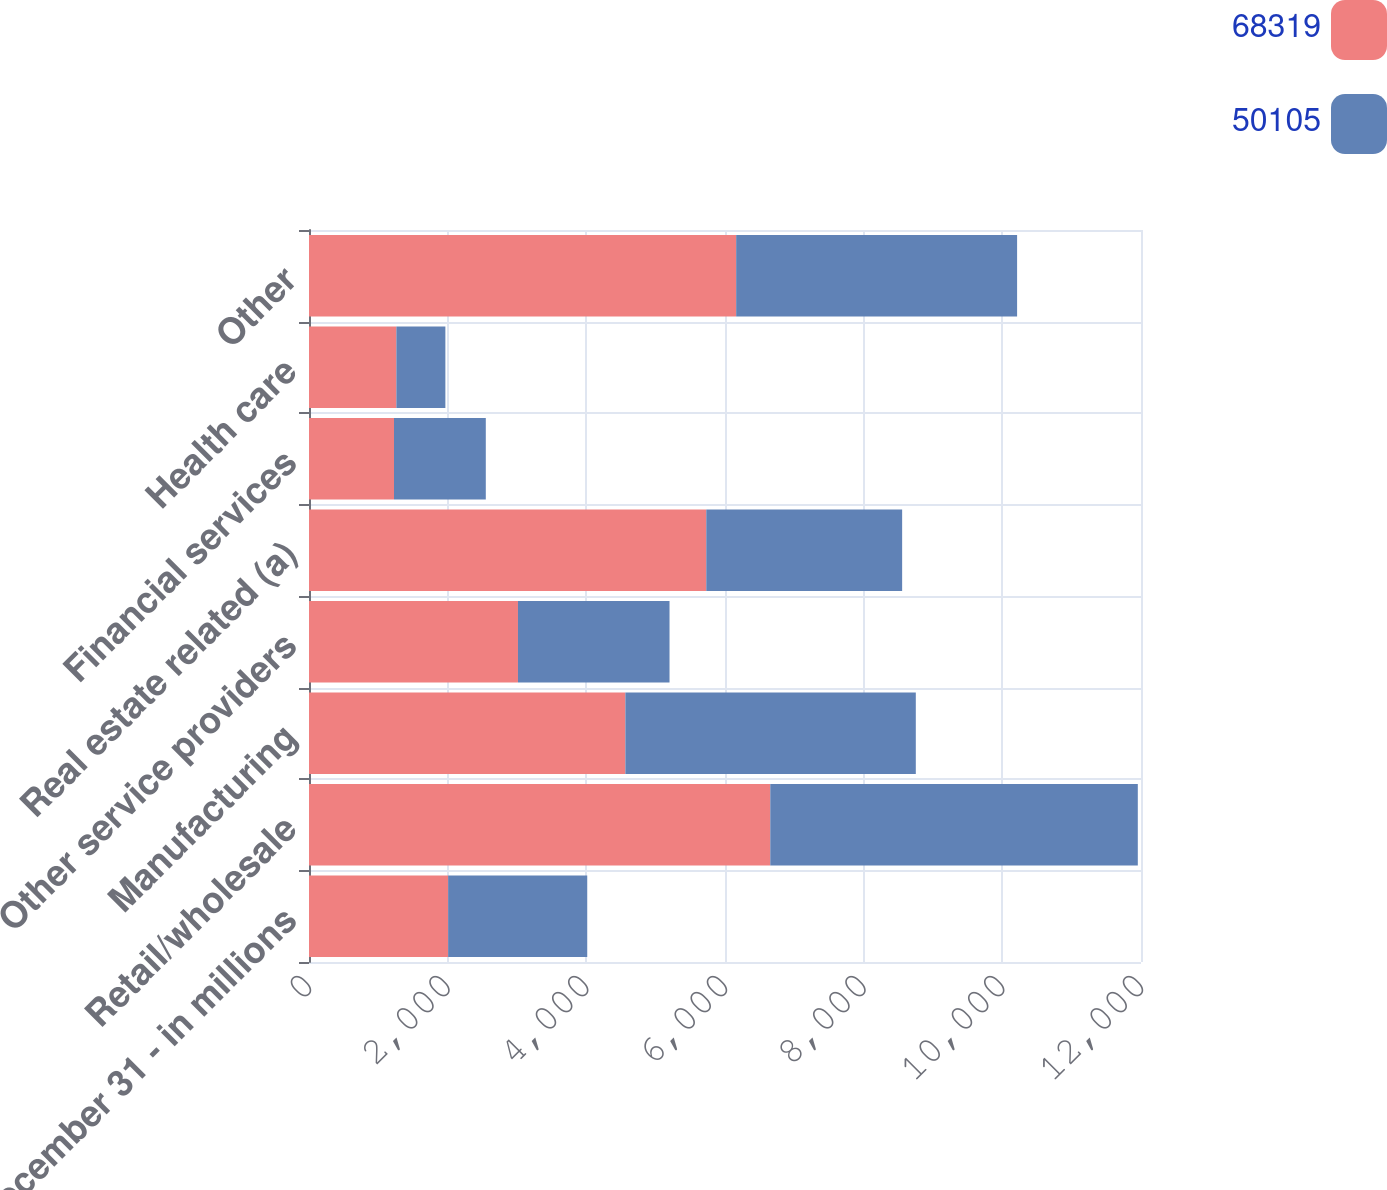Convert chart to OTSL. <chart><loc_0><loc_0><loc_500><loc_500><stacked_bar_chart><ecel><fcel>December 31 - in millions<fcel>Retail/wholesale<fcel>Manufacturing<fcel>Other service providers<fcel>Real estate related (a)<fcel>Financial services<fcel>Health care<fcel>Other<nl><fcel>68319<fcel>2007<fcel>6653<fcel>4563<fcel>3014<fcel>5730<fcel>1226<fcel>1260<fcel>6161<nl><fcel>50105<fcel>2006<fcel>5301<fcel>4189<fcel>2186<fcel>2825<fcel>1324<fcel>707<fcel>4052<nl></chart> 